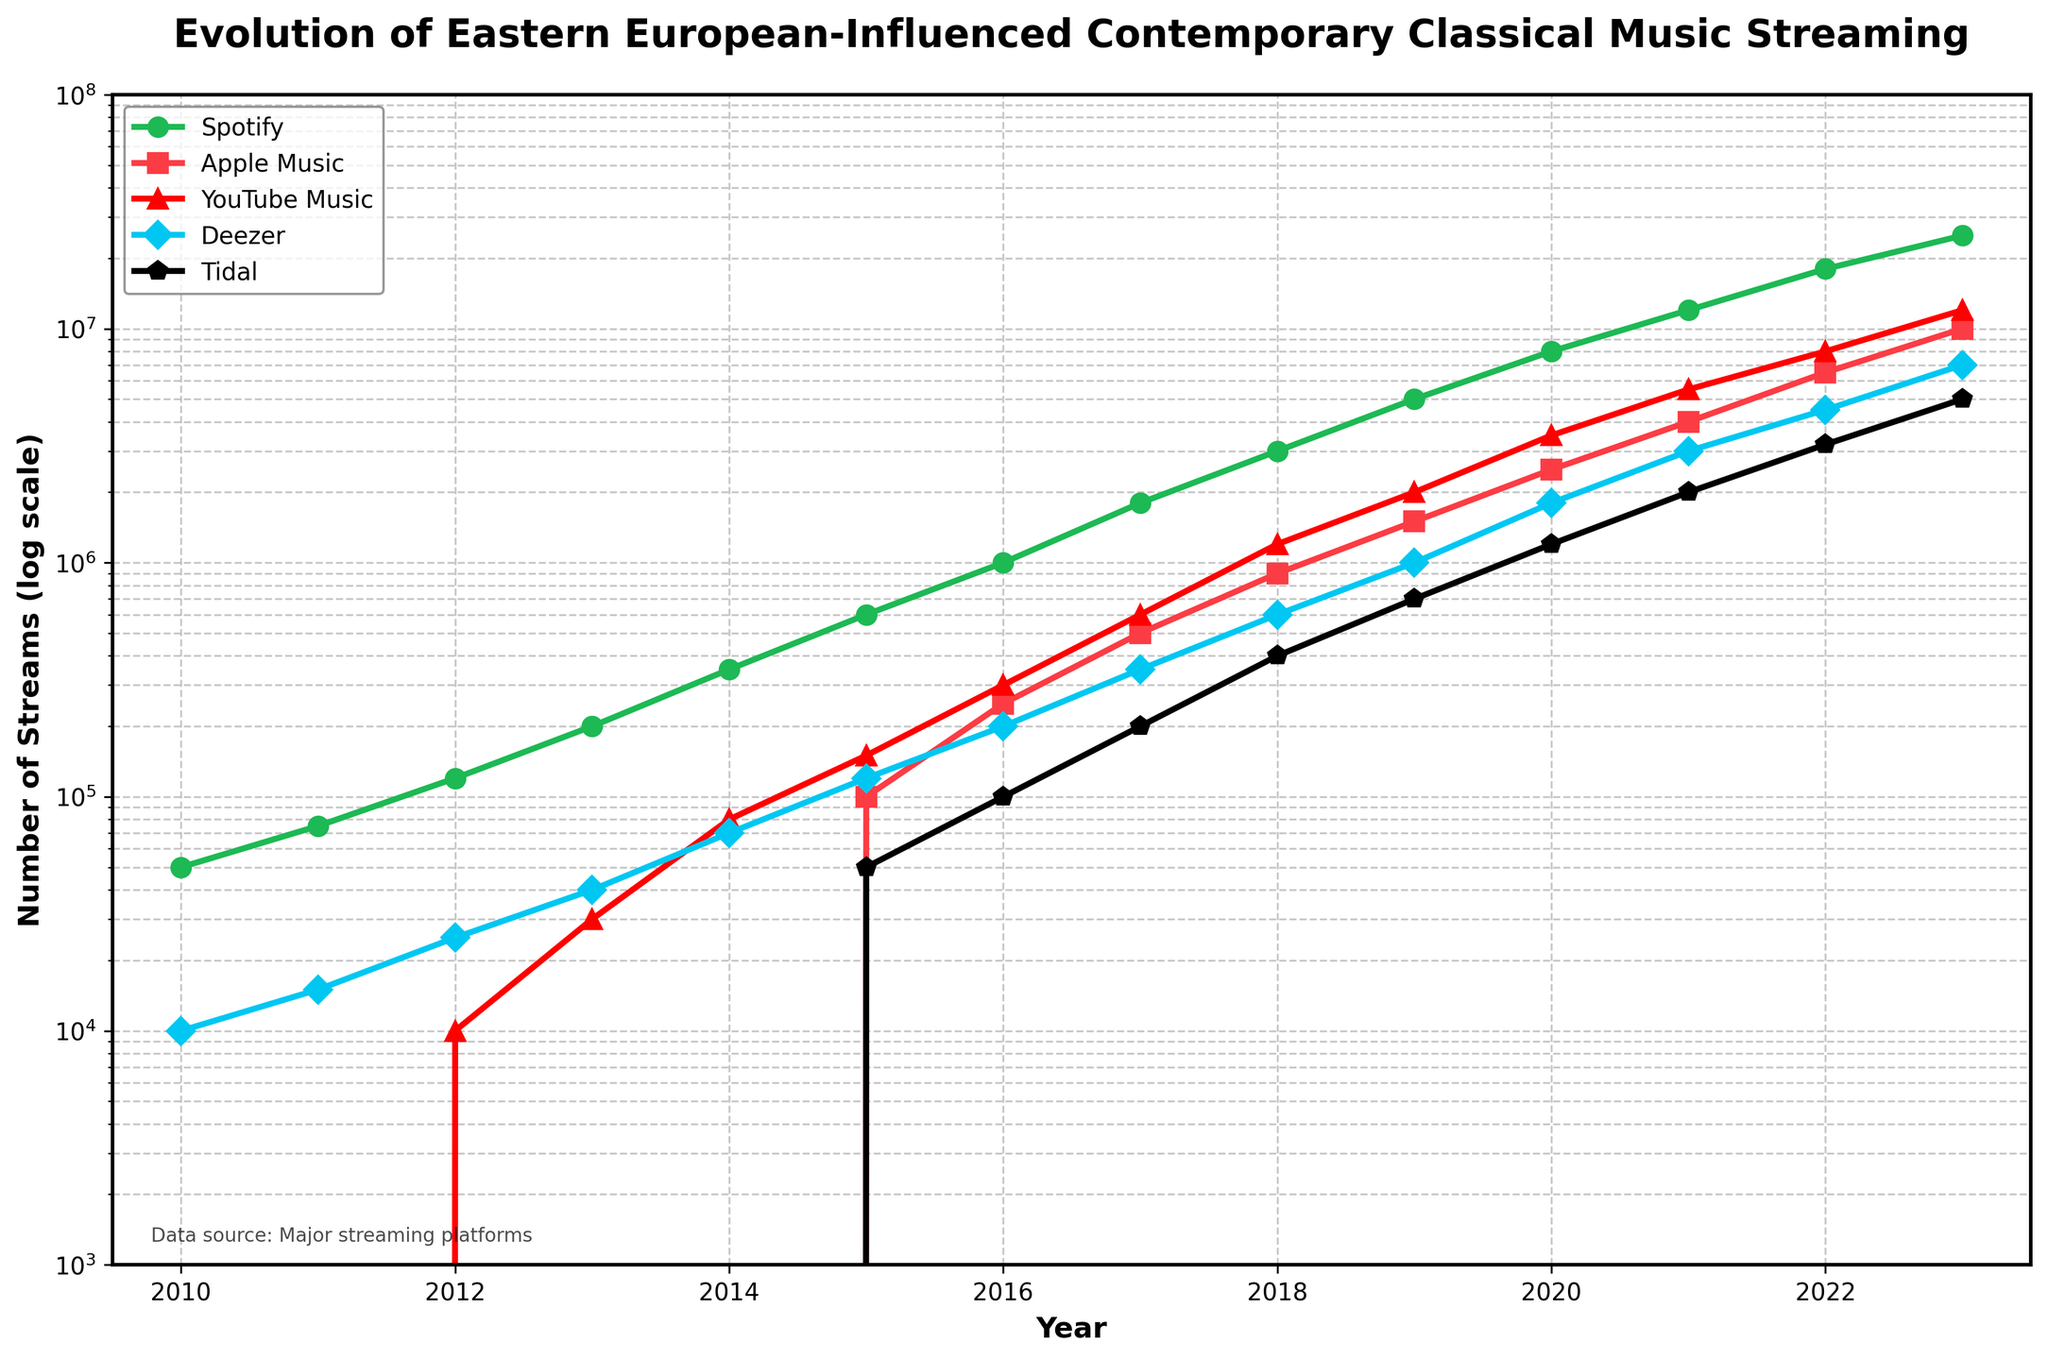What's the overall trend in the number of streams for Spotify from 2010 to 2023? There is a steady increase in the number of streams for Spotify from 2010 to 2023, starting at 50,000 streams in 2010 and reaching 25,000,000 streams in 2023. The trend shows exponential growth.
Answer: The trend is an exponential increase Which platform had the highest number of streams in 2023? By observing the data points for 2023, Spotify has the highest number of streams with 25,000,000 streams.
Answer: Spotify How does the number of streams on Apple Music in 2017 compare to YouTube Music in the same year? From the chart, we can see that Apple Music had 500,000 streams in 2017, whereas YouTube Music had 600,000 streams. Therefore, YouTube Music had a higher number of streams.
Answer: YouTube Music had more streams What is the total number of streams across all platforms in 2015? The number of streams in 2015 for each platform is: Spotify - 600,000, Apple Music - 100,000, YouTube Music - 150,000, Deezer - 120,000, Tidal - 50,000. Summing these values gives 600,000 + 100,000 + 150,000 + 120,000 + 50,000 = 1,020,000.
Answer: 1,020,000 Which platform showed the most significant increase in streams between 2010 and 2023? To determine the most significant increase, we look at the increase for each platform: Spotify (25,000,000 - 50,000), Apple Music (10,000,000 - 0), YouTube Music (12,000,000 - 0), Deezer (7,000,000 - 10,000), and Tidal (5,000,000 - 0). Spotify shows the most significant increase of 24,950,000.
Answer: Spotify Identify the year when Deezer surpassed 1,000,000 streams. By examining the Deezer line, we see it surpassed 1,000,000 streams in 2019.
Answer: 2019 What’s the ratio of streams between Spotify and Tidal in 2020? In 2020, Spotify had 8,000,000 streams and Tidal had 1,200,000 streams. The ratio is calculated as 8,000,000 / 1,200,000, which simplifies to 6.67.
Answer: 6.67 In which year did YouTube Music first surpass 1,000,000 streams? Observing the chart, YouTube Music surpassed 1,000,000 streams in 2018.
Answer: 2018 Which platform had no streams before 2015? Observing the data, Apple Music, YouTube Music, and Tidal all had zero streams before 2015.
Answer: Apple Music, YouTube Music, Tidal 